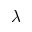Convert formula to latex. <formula><loc_0><loc_0><loc_500><loc_500>\lambda</formula> 